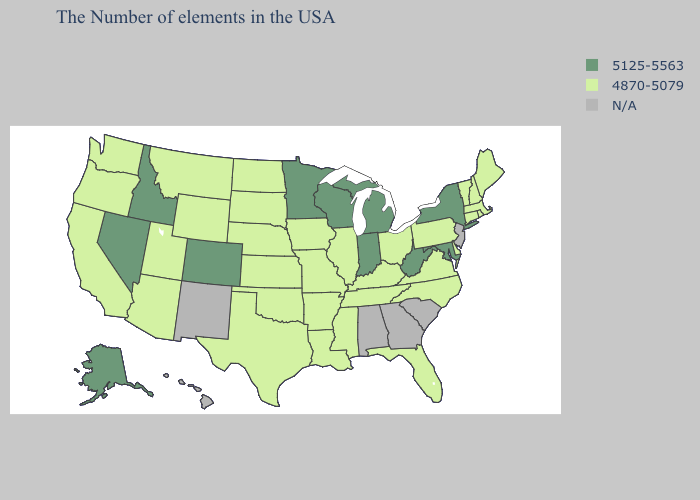Among the states that border Indiana , does Kentucky have the lowest value?
Be succinct. Yes. What is the value of New Hampshire?
Short answer required. 4870-5079. Among the states that border South Dakota , which have the lowest value?
Write a very short answer. Iowa, Nebraska, North Dakota, Wyoming, Montana. Does Wisconsin have the highest value in the USA?
Short answer required. Yes. Name the states that have a value in the range 5125-5563?
Keep it brief. New York, Maryland, West Virginia, Michigan, Indiana, Wisconsin, Minnesota, Colorado, Idaho, Nevada, Alaska. How many symbols are there in the legend?
Write a very short answer. 3. Name the states that have a value in the range N/A?
Give a very brief answer. New Jersey, South Carolina, Georgia, Alabama, New Mexico, Hawaii. What is the value of California?
Concise answer only. 4870-5079. How many symbols are there in the legend?
Be succinct. 3. What is the value of Colorado?
Answer briefly. 5125-5563. What is the value of Texas?
Write a very short answer. 4870-5079. What is the highest value in the USA?
Be succinct. 5125-5563. What is the lowest value in the Northeast?
Write a very short answer. 4870-5079. What is the lowest value in states that border Michigan?
Short answer required. 4870-5079. 